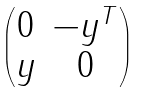<formula> <loc_0><loc_0><loc_500><loc_500>\begin{pmatrix} 0 & - y ^ { T } \\ y & 0 \end{pmatrix}</formula> 